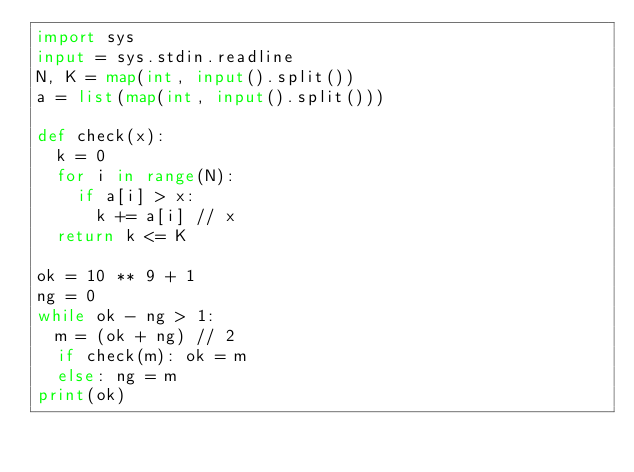Convert code to text. <code><loc_0><loc_0><loc_500><loc_500><_Python_>import sys
input = sys.stdin.readline
N, K = map(int, input().split())
a = list(map(int, input().split()))

def check(x):
  k = 0
  for i in range(N):
    if a[i] > x:
      k += a[i] // x
  return k <= K

ok = 10 ** 9 + 1
ng = 0
while ok - ng > 1:
  m = (ok + ng) // 2
  if check(m): ok = m
  else: ng = m
print(ok)</code> 